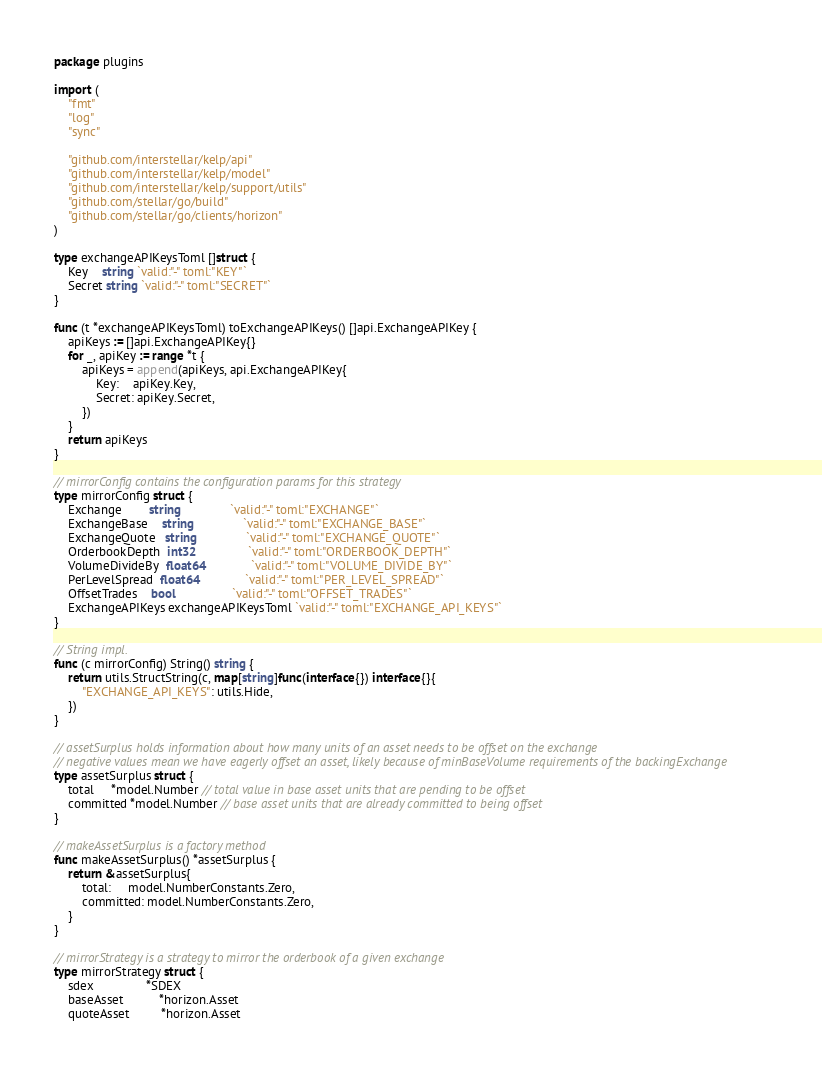<code> <loc_0><loc_0><loc_500><loc_500><_Go_>package plugins

import (
	"fmt"
	"log"
	"sync"

	"github.com/interstellar/kelp/api"
	"github.com/interstellar/kelp/model"
	"github.com/interstellar/kelp/support/utils"
	"github.com/stellar/go/build"
	"github.com/stellar/go/clients/horizon"
)

type exchangeAPIKeysToml []struct {
	Key    string `valid:"-" toml:"KEY"`
	Secret string `valid:"-" toml:"SECRET"`
}

func (t *exchangeAPIKeysToml) toExchangeAPIKeys() []api.ExchangeAPIKey {
	apiKeys := []api.ExchangeAPIKey{}
	for _, apiKey := range *t {
		apiKeys = append(apiKeys, api.ExchangeAPIKey{
			Key:    apiKey.Key,
			Secret: apiKey.Secret,
		})
	}
	return apiKeys
}

// mirrorConfig contains the configuration params for this strategy
type mirrorConfig struct {
	Exchange        string              `valid:"-" toml:"EXCHANGE"`
	ExchangeBase    string              `valid:"-" toml:"EXCHANGE_BASE"`
	ExchangeQuote   string              `valid:"-" toml:"EXCHANGE_QUOTE"`
	OrderbookDepth  int32               `valid:"-" toml:"ORDERBOOK_DEPTH"`
	VolumeDivideBy  float64             `valid:"-" toml:"VOLUME_DIVIDE_BY"`
	PerLevelSpread  float64             `valid:"-" toml:"PER_LEVEL_SPREAD"`
	OffsetTrades    bool                `valid:"-" toml:"OFFSET_TRADES"`
	ExchangeAPIKeys exchangeAPIKeysToml `valid:"-" toml:"EXCHANGE_API_KEYS"`
}

// String impl.
func (c mirrorConfig) String() string {
	return utils.StructString(c, map[string]func(interface{}) interface{}{
		"EXCHANGE_API_KEYS": utils.Hide,
	})
}

// assetSurplus holds information about how many units of an asset needs to be offset on the exchange
// negative values mean we have eagerly offset an asset, likely because of minBaseVolume requirements of the backingExchange
type assetSurplus struct {
	total     *model.Number // total value in base asset units that are pending to be offset
	committed *model.Number // base asset units that are already committed to being offset
}

// makeAssetSurplus is a factory method
func makeAssetSurplus() *assetSurplus {
	return &assetSurplus{
		total:     model.NumberConstants.Zero,
		committed: model.NumberConstants.Zero,
	}
}

// mirrorStrategy is a strategy to mirror the orderbook of a given exchange
type mirrorStrategy struct {
	sdex               *SDEX
	baseAsset          *horizon.Asset
	quoteAsset         *horizon.Asset</code> 